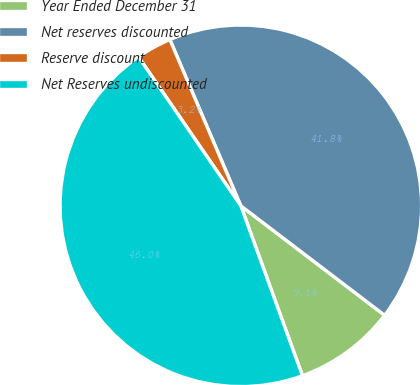Convert chart to OTSL. <chart><loc_0><loc_0><loc_500><loc_500><pie_chart><fcel>Year Ended December 31<fcel>Net reserves discounted<fcel>Reserve discount<fcel>Net Reserves undiscounted<nl><fcel>9.11%<fcel>41.78%<fcel>3.16%<fcel>45.96%<nl></chart> 